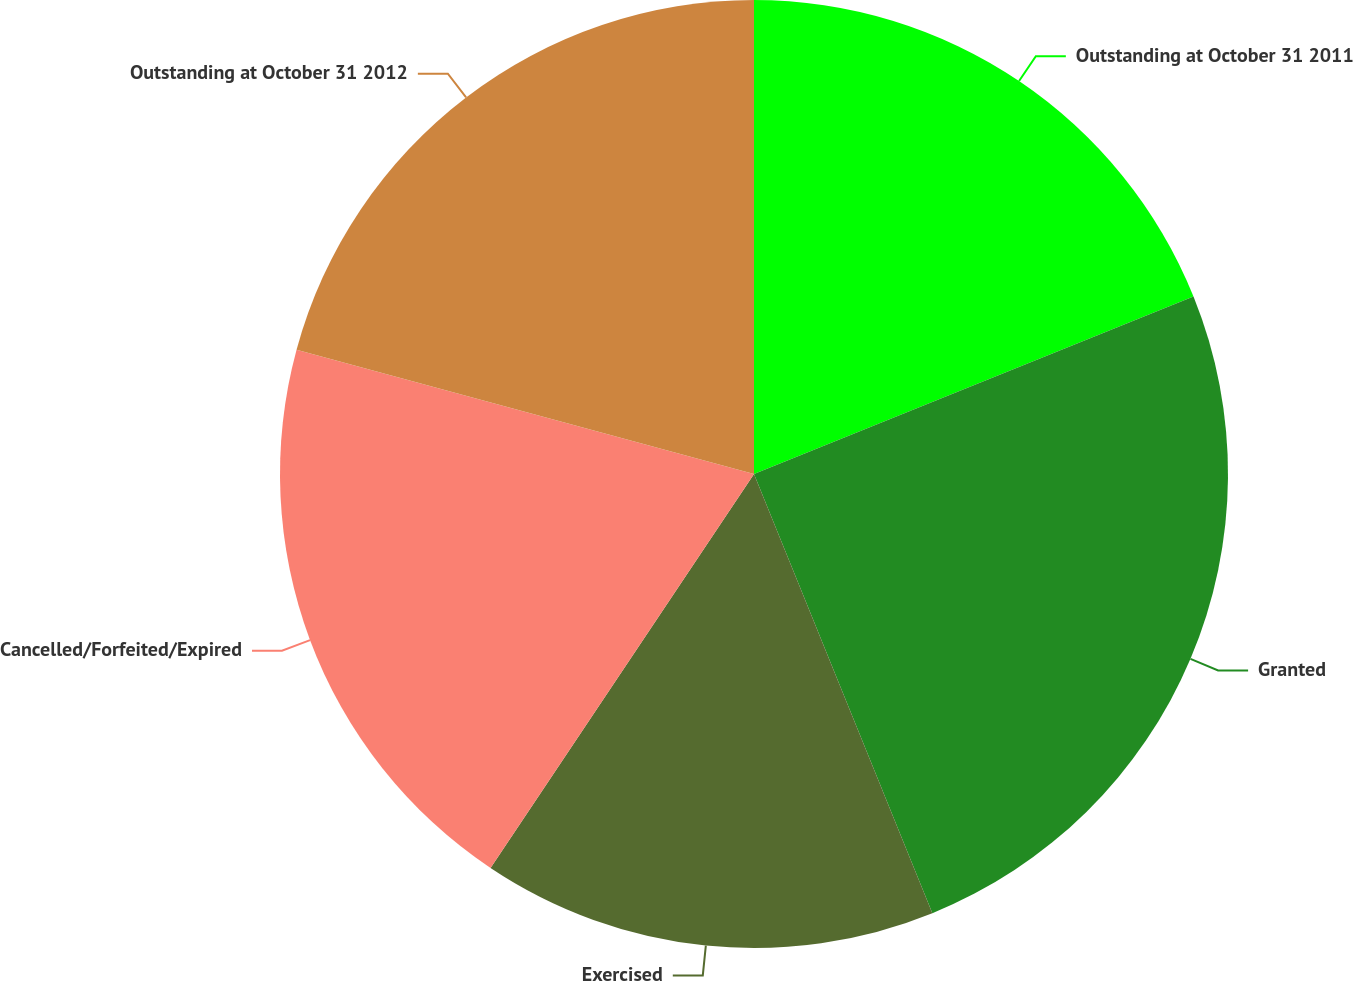Convert chart. <chart><loc_0><loc_0><loc_500><loc_500><pie_chart><fcel>Outstanding at October 31 2011<fcel>Granted<fcel>Exercised<fcel>Cancelled/Forfeited/Expired<fcel>Outstanding at October 31 2012<nl><fcel>18.89%<fcel>24.97%<fcel>15.52%<fcel>19.84%<fcel>20.78%<nl></chart> 